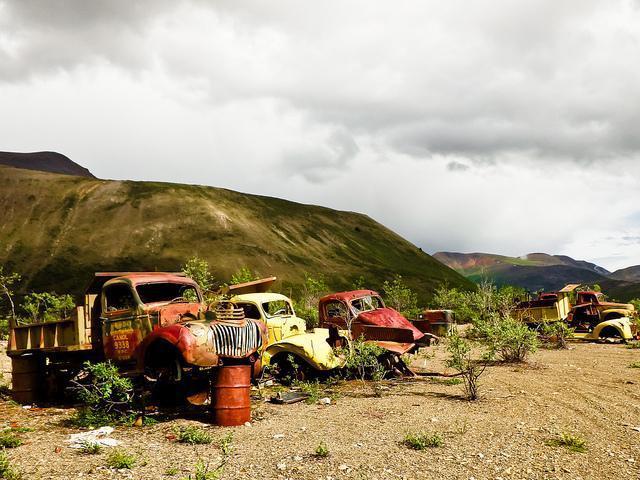How many trucks are there?
Give a very brief answer. 4. 